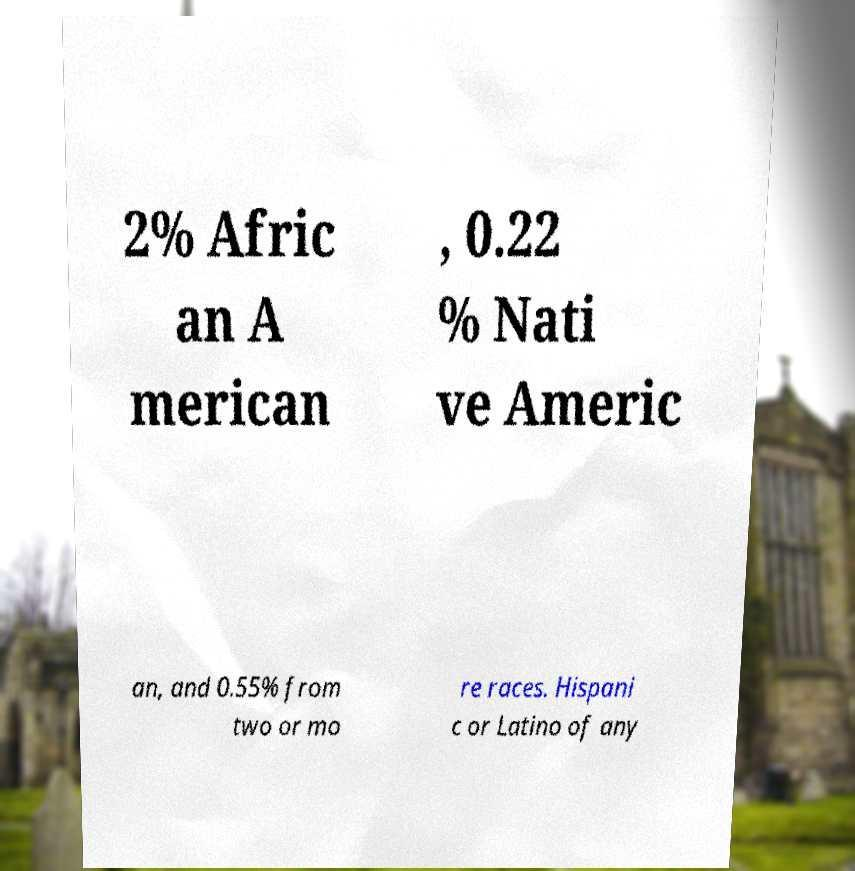Could you assist in decoding the text presented in this image and type it out clearly? 2% Afric an A merican , 0.22 % Nati ve Americ an, and 0.55% from two or mo re races. Hispani c or Latino of any 